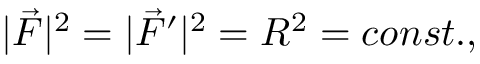<formula> <loc_0><loc_0><loc_500><loc_500>| \vec { F } | ^ { 2 } = | \vec { F } ^ { \prime } | ^ { 2 } = R ^ { 2 } = c o n s t . ,</formula> 